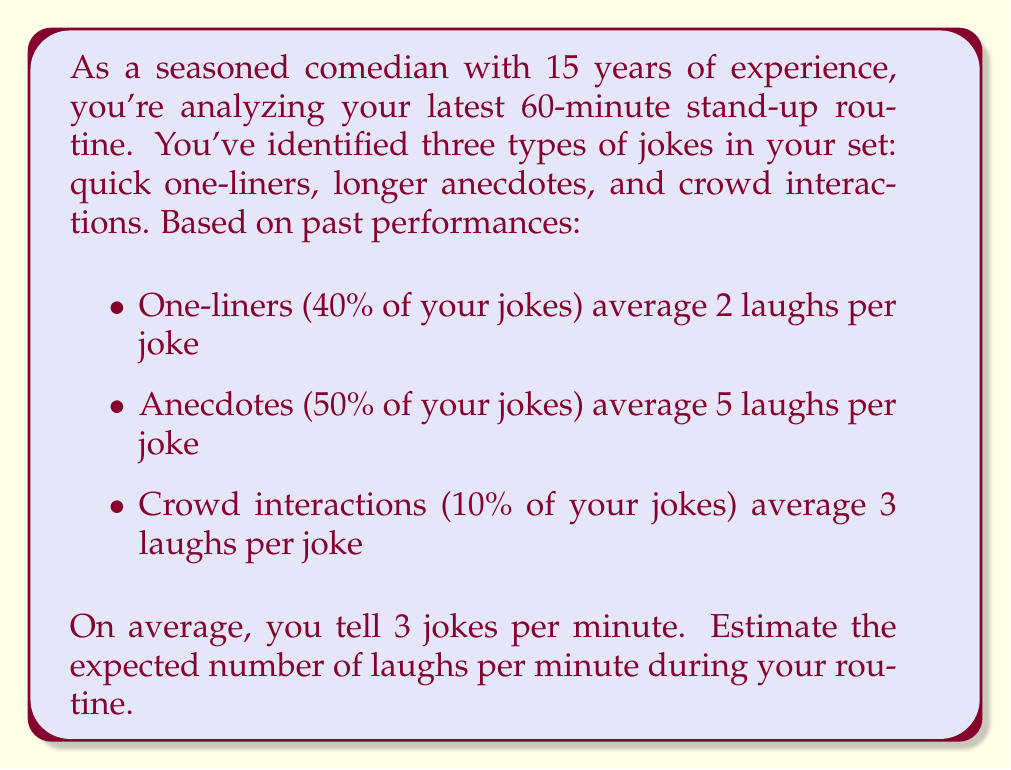What is the answer to this math problem? Let's approach this step-by-step:

1) First, we need to calculate the expected number of laughs per joke:

   Let $E(L)$ be the expected number of laughs per joke.
   
   $E(L) = 0.4 \cdot 2 + 0.5 \cdot 5 + 0.1 \cdot 3$
   
   $E(L) = 0.8 + 2.5 + 0.3 = 3.6$ laughs per joke

2) Now, we know that on average, you tell 3 jokes per minute. Let's call the number of jokes per minute $J$.

3) The expected number of laughs per minute, $E(LPM)$, is the product of the expected laughs per joke and the number of jokes per minute:

   $E(LPM) = E(L) \cdot J$
   
   $E(LPM) = 3.6 \cdot 3 = 10.8$

Therefore, the expected number of laughs per minute during your routine is 10.8.
Answer: 10.8 laughs per minute 